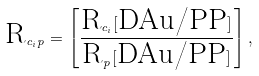Convert formula to latex. <formula><loc_0><loc_0><loc_500><loc_500>\text {R} _ { c _ { i } p } = \left [ \frac { \text {R} _ { c _ { i } } [ { \text {DAu/PP} } ] } { \text {R} _ { p } [ \text {DAu/PP} ] } \right ] ,</formula> 